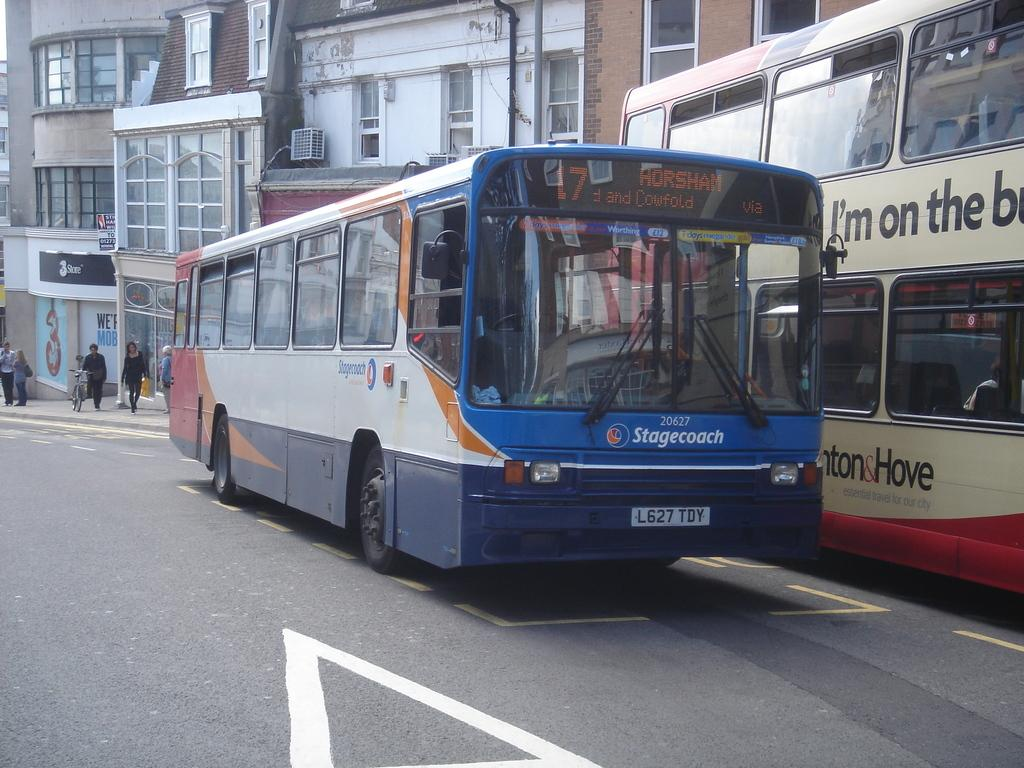<image>
Present a compact description of the photo's key features. Stagecoach number 20627 is going to Horsham on its route. 